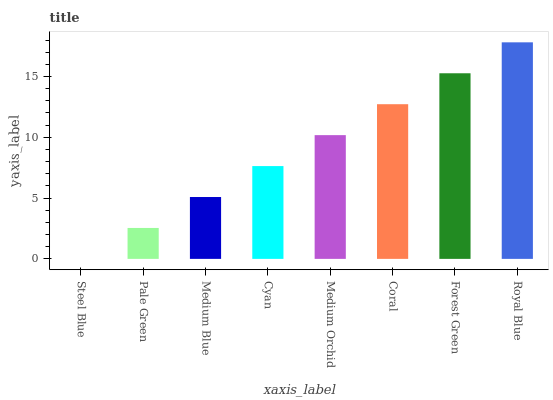Is Steel Blue the minimum?
Answer yes or no. Yes. Is Royal Blue the maximum?
Answer yes or no. Yes. Is Pale Green the minimum?
Answer yes or no. No. Is Pale Green the maximum?
Answer yes or no. No. Is Pale Green greater than Steel Blue?
Answer yes or no. Yes. Is Steel Blue less than Pale Green?
Answer yes or no. Yes. Is Steel Blue greater than Pale Green?
Answer yes or no. No. Is Pale Green less than Steel Blue?
Answer yes or no. No. Is Medium Orchid the high median?
Answer yes or no. Yes. Is Cyan the low median?
Answer yes or no. Yes. Is Medium Blue the high median?
Answer yes or no. No. Is Pale Green the low median?
Answer yes or no. No. 